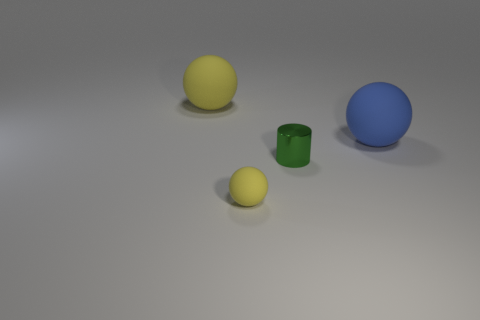Subtract all blue rubber spheres. How many spheres are left? 2 Add 1 cyan blocks. How many objects exist? 5 Subtract all blue balls. How many balls are left? 2 Subtract all spheres. How many objects are left? 1 Add 1 large red matte blocks. How many large red matte blocks exist? 1 Subtract 1 green cylinders. How many objects are left? 3 Subtract all cyan spheres. Subtract all brown cubes. How many spheres are left? 3 Subtract all cyan balls. How many blue cylinders are left? 0 Subtract all big blue rubber things. Subtract all blue objects. How many objects are left? 2 Add 4 small things. How many small things are left? 6 